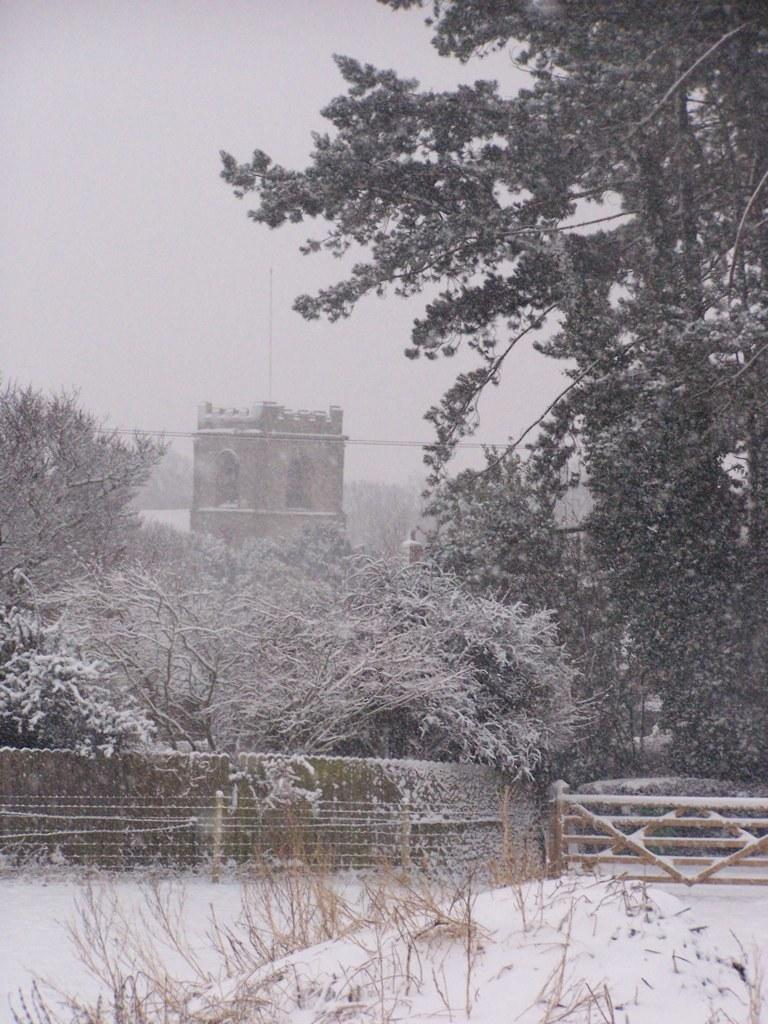What type of vegetation can be seen in the image? There are trees in the image. What is the condition of the trees in the image? The trees are covered with snow. What other structure is visible in the image? There is a fence wall in the image. How is the fence wall affected by the snow in the image? The fence wall is also covered with snow. How many basketballs can be seen hanging from the trees in the image? There are no basketballs present in the image; it features trees and a fence wall covered with snow. 